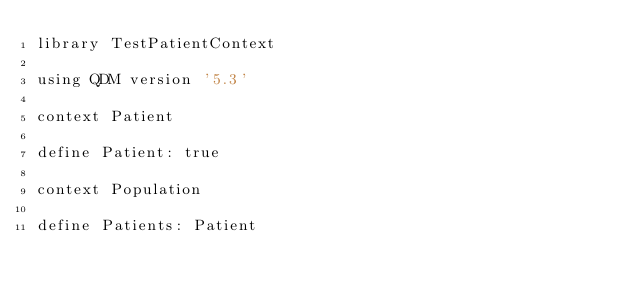Convert code to text. <code><loc_0><loc_0><loc_500><loc_500><_SQL_>library TestPatientContext

using QDM version '5.3'

context Patient

define Patient: true

context Population

define Patients: Patient</code> 